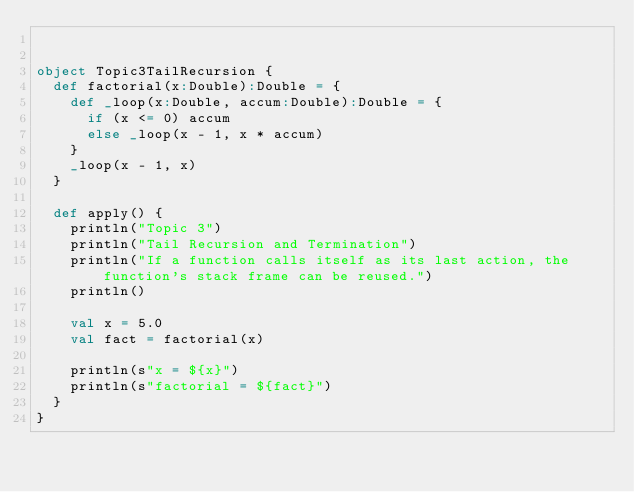Convert code to text. <code><loc_0><loc_0><loc_500><loc_500><_Scala_>

object Topic3TailRecursion {
  def factorial(x:Double):Double = {
    def _loop(x:Double, accum:Double):Double = {
      if (x <= 0) accum
      else _loop(x - 1, x * accum)
    }
    _loop(x - 1, x)
  }
  
  def apply() {
    println("Topic 3")
    println("Tail Recursion and Termination")
    println("If a function calls itself as its last action, the function's stack frame can be reused.")
    println()
    
    val x = 5.0
    val fact = factorial(x)
    
    println(s"x = ${x}")
    println(s"factorial = ${fact}")
  }
}</code> 